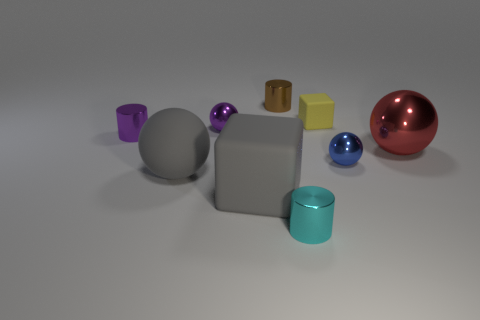What number of small brown cylinders are to the left of the purple thing on the left side of the small shiny ball that is left of the small yellow block?
Your response must be concise. 0. How many blue objects are small metal objects or large cylinders?
Your response must be concise. 1. There is a gray block; is its size the same as the shiny cylinder behind the yellow object?
Provide a succinct answer. No. There is a small cyan thing that is the same shape as the small brown metallic thing; what material is it?
Offer a terse response. Metal. What number of other objects are there of the same size as the purple ball?
Give a very brief answer. 5. There is a large rubber thing behind the block that is on the left side of the cylinder behind the yellow matte thing; what is its shape?
Your answer should be compact. Sphere. What is the shape of the small metal thing that is both left of the tiny brown metallic object and right of the gray sphere?
Your answer should be compact. Sphere. How many things are large cyan cylinders or tiny metallic spheres that are to the right of the tiny matte object?
Provide a short and direct response. 1. Are the purple sphere and the yellow thing made of the same material?
Give a very brief answer. No. What number of other objects are there of the same shape as the cyan object?
Give a very brief answer. 2. 